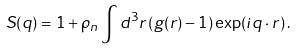<formula> <loc_0><loc_0><loc_500><loc_500>S ( { q } ) = 1 + \rho _ { n } \int d ^ { 3 } r \left ( g ( { r } ) - 1 \right ) \exp ( i { q } \cdot { r } ) \, .</formula> 